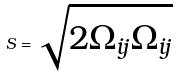<formula> <loc_0><loc_0><loc_500><loc_500>S = \sqrt { 2 \Omega _ { i j } \Omega _ { i j } }</formula> 